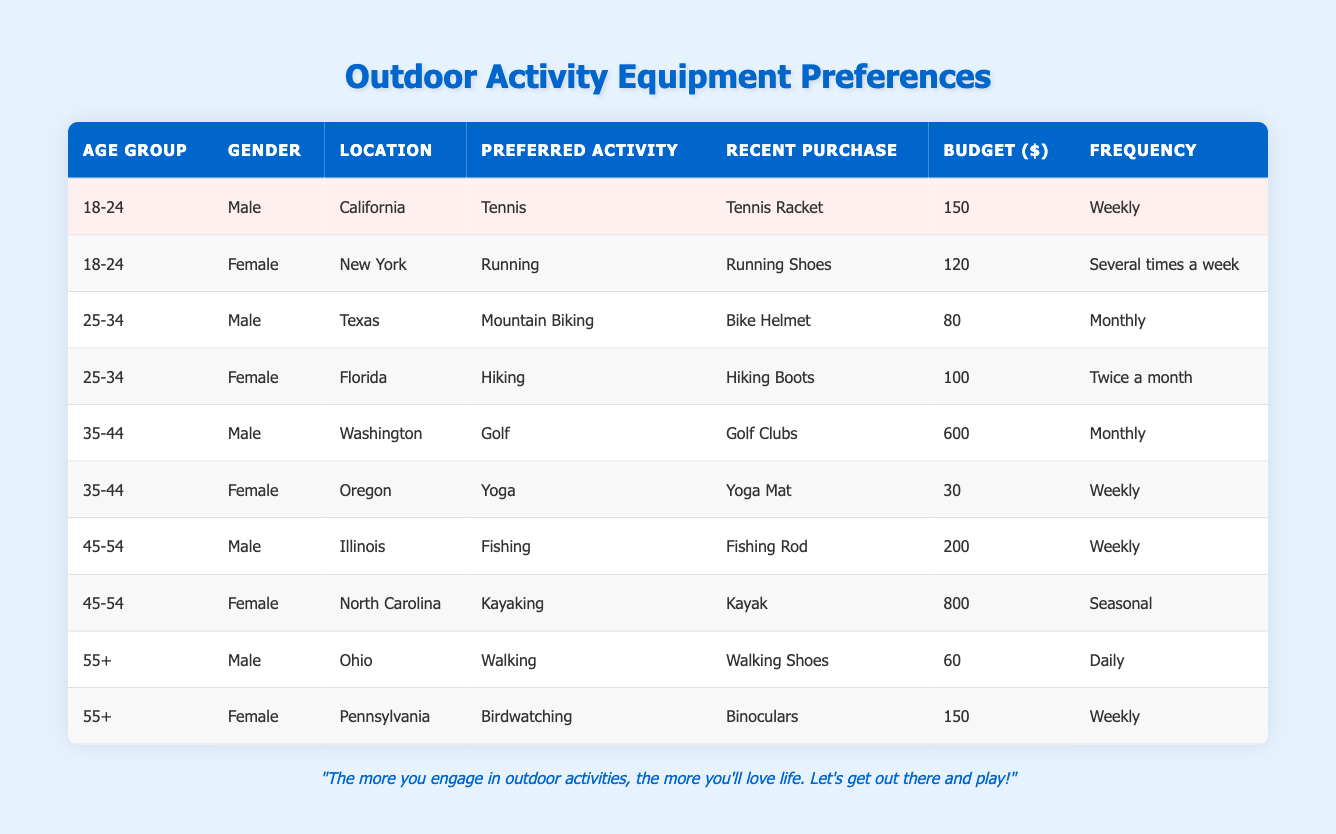What is the preferred outdoor activity of the individual from Florida? The individual from Florida belongs to the age group 25-34 and their preferred outdoor activity is listed as Hiking.
Answer: Hiking How much did the male from California spend on his recent purchase? The male from California in the 18-24 age group spent $150 on a Tennis Racket, which is noted in the table under Recent Purchase and Budget.
Answer: $150 Is there any female in the 45-54 age group who has purchased a kayak? Yes, the female from North Carolina in the 45-54 age group has purchased a kayak, as specified in the table.
Answer: Yes What is the average budget spent on recent purchases by males in the 35-44 age group? The recent purchases for males in this age group were Golf Clubs for $600. Since there is only one male in this group, the average is simply $600.
Answer: $600 How often does the female from New York engage in her preferred outdoor activity? The female from New York in the 18-24 age group engages in her preferred activity, Running, several times a week, as stated in the Frequency column.
Answer: Several times a week What is the total budget of the respondents who prefer Walking and Birdwatching? The male who prefers Walking has a budget of $60, and the female who prefers Birdwatching has a budget of $150. Adding these gives a total budget of $210 ($60 + $150).
Answer: $210 Is there anyone in the 55+ age group who has a frequency of activities listed as daily? Yes, the male from Ohio in the 55+ age group engages in Walking daily, as per the information given in the table.
Answer: Yes Which outdoor activity has the highest reported budget among all the respondents? The female from North Carolina has the highest reported budget of $800 for Kayaking, which is the maximum value in the Budget column across all entries.
Answer: Kayaking How many respondents reported purchasing equipment with a budget of over $200? There are three respondents with budgets over $200: the male in the 35-44 age group ($600 for Golf Clubs), the female in the 45-54 age group ($800 for a Kayak), and the male in the 45-54 age group ($200 for a Fishing Rod).
Answer: 3 What percentage of the respondents participate in their preferred outdoor activities weekly? Four respondents (the male from California, the female from Oregon, the male from Illinois, and the female from Pennsylvania) have a frequency of Activities as Weekly out of a total of ten respondents. Therefore, the percentage is (4/10) * 100 = 40%.
Answer: 40% 